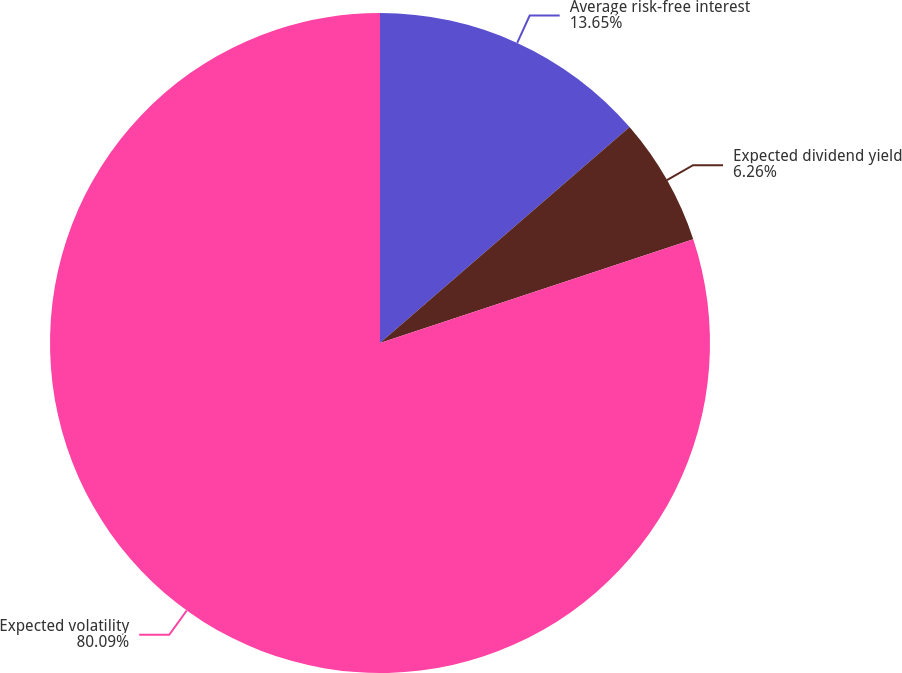Convert chart to OTSL. <chart><loc_0><loc_0><loc_500><loc_500><pie_chart><fcel>Average risk-free interest<fcel>Expected dividend yield<fcel>Expected volatility<nl><fcel>13.65%<fcel>6.26%<fcel>80.09%<nl></chart> 